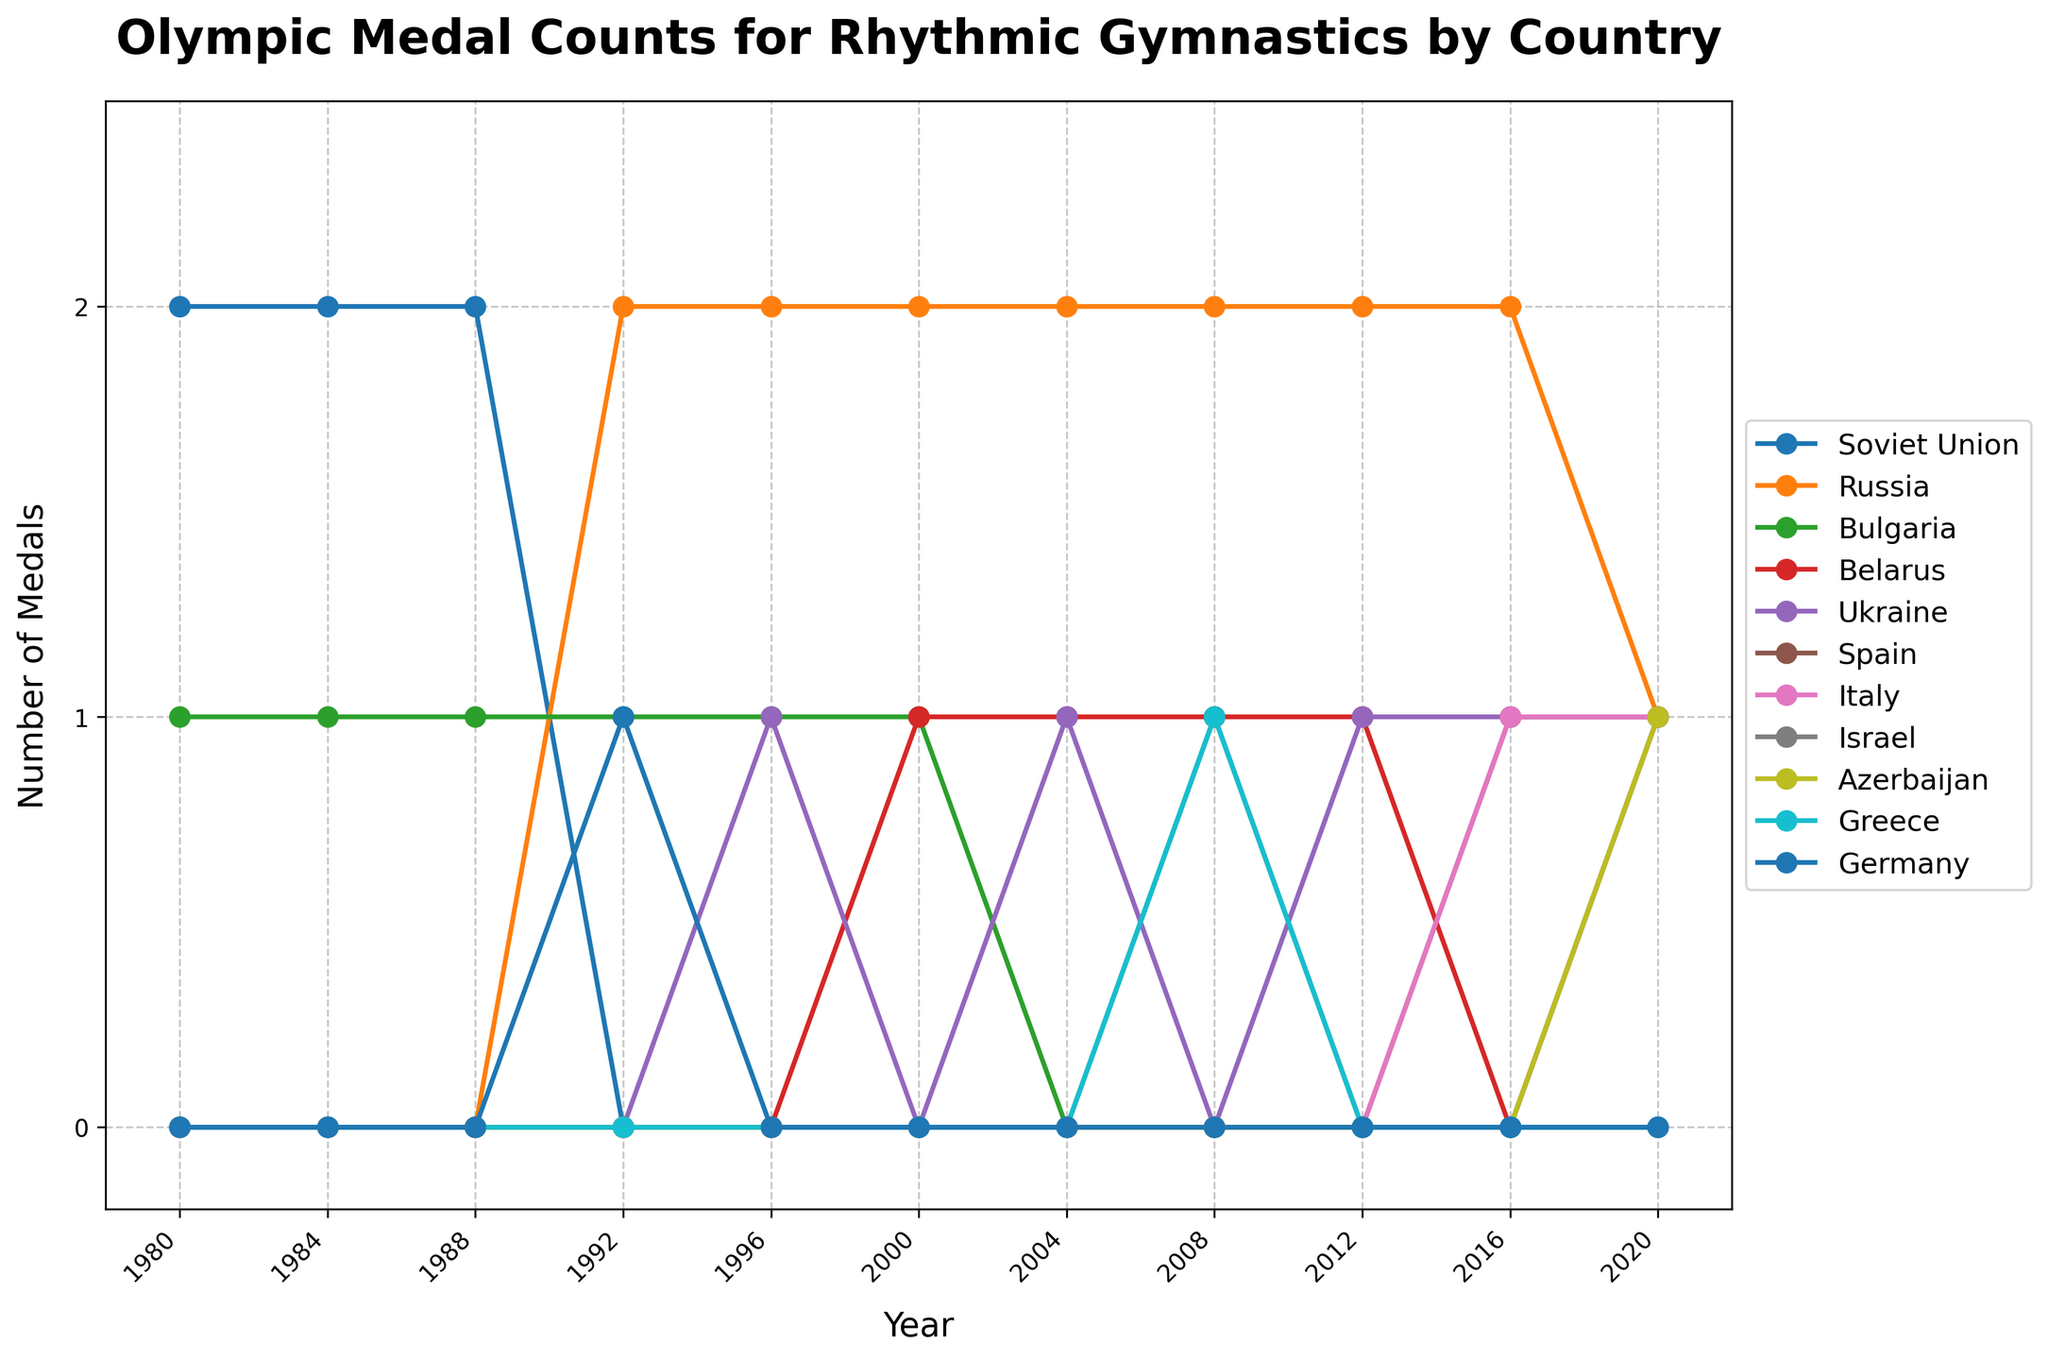Who has the highest total number of medals over the last 40 years? To find the country with the highest total number of medals, sum the medals for each country across all years. Russia has the highest total with 14 medals.
Answer: Russia Which country had a consistent number of medals from 1992 to 2012 and how many medals did they win each time? Look at the lines that remain constant from 1992 to 2012. Russia consistently won 2 medals each time.
Answer: Russia, 2 medals In which year did Spain win its first medal in rhythmic gymnastics? Look at Spain's line and identify the first year it rises above zero. Spain won its first medal in 2016.
Answer: 2016 How many medals did Belarus win in total from 2000 to 2020? Sum the number of medals for Belarus from 2000 to 2020: 1+1+1+1+0+1 = 5 medals.
Answer: 5 Which year shows the highest combined total number of medals among all countries? Add the number of medals for all countries for each year and identify the year with the highest sum. The year 1996 shows the highest combined total of 3 medals (Russia 2, Ukraine 1).
Answer: 1996 When did Italy win its first medal in rhythmic gymnastics? Look at Italy's line and find the first year it rises above zero. Italy won its first medal in 2016.
Answer: 2016 Which countries had an increase in the number of medals from 2016 to 2020? Compare the number of medals each country had in 2016 and 2020. Israel and Azerbaijan each increased from 0 to 1 medal.
Answer: Israel, Azerbaijan How many more medals did Russia win compared to Bulgaria from 1980 to 2020? Calculate the total medals of Russia and Bulgaria, then subtract Bulgaria's total from Russia's total: Russia 14, Bulgaria 6. The difference is 8 medals.
Answer: 8 Which countries did not win any medals in the period between 2004 and 2020? Look for countries with zero medals in all years from 2004 to 2020. Germany did not win any medals in this period.
Answer: Germany 